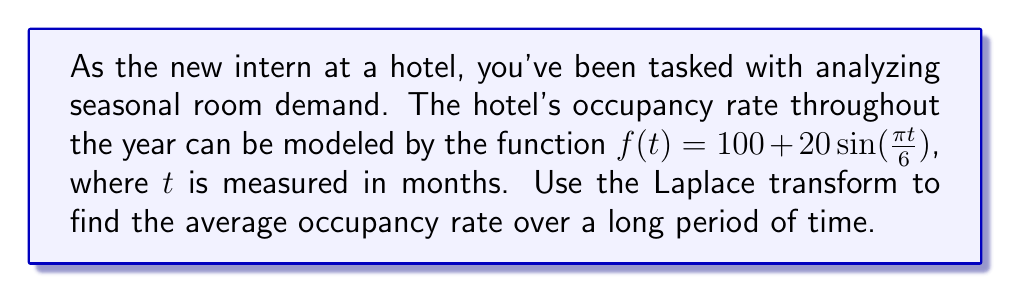Can you solve this math problem? To solve this problem, we'll follow these steps:

1) First, recall the Laplace transform of a sinusoidal function:

   $\mathcal{L}\{a\sin(bt)\} = \frac{ab}{s^2 + b^2}$

2) In our case, $a = 20$ and $b = \frac{\pi}{6}$. The constant term 100 transforms to $\frac{100}{s}$.

3) Therefore, the Laplace transform of our function is:

   $$F(s) = \mathcal{L}\{f(t)\} = \frac{100}{s} + \frac{20(\frac{\pi}{6})}{s^2 + (\frac{\pi}{6})^2}$$

4) To find the long-term average, we use the Final Value Theorem:

   $$\lim_{t \to \infty} f(t) = \lim_{s \to 0} sF(s)$$

5) Applying this to our transformed function:

   $$\lim_{s \to 0} s(\frac{100}{s} + \frac{20(\frac{\pi}{6})}{s^2 + (\frac{\pi}{6})^2})$$

6) As $s$ approaches 0, the second term approaches 0:

   $$\lim_{s \to 0} (100 + \frac{20(\frac{\pi}{6})s}{s^2 + (\frac{\pi}{6})^2}) = 100$$

Therefore, the average occupancy rate over a long period of time is 100 rooms.
Answer: 100 rooms 